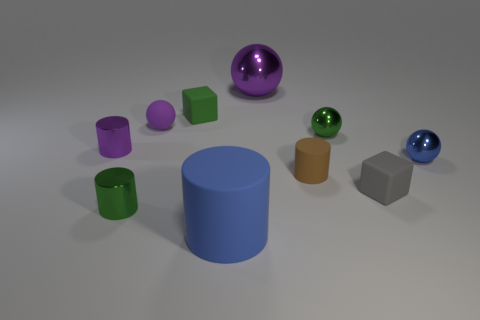Is there a tiny metallic thing that is on the left side of the large thing behind the big blue thing?
Your answer should be compact. Yes. There is a small rubber cube that is left of the small rubber block that is to the right of the green matte thing; how many tiny brown things are on the left side of it?
Offer a terse response. 0. There is a small shiny object that is both to the left of the big blue thing and behind the blue metallic sphere; what is its color?
Offer a terse response. Purple. How many small cylinders have the same color as the tiny matte ball?
Your response must be concise. 1. How many balls are either large gray metal things or brown matte objects?
Provide a short and direct response. 0. The other rubber cube that is the same size as the green cube is what color?
Your answer should be very brief. Gray. There is a brown cylinder on the left side of the green metallic object to the right of the purple shiny sphere; are there any small brown matte objects that are behind it?
Make the answer very short. No. What is the size of the green block?
Your response must be concise. Small. How many things are either tiny yellow matte cylinders or big purple shiny objects?
Provide a short and direct response. 1. What is the color of the other cylinder that is the same material as the big blue cylinder?
Your response must be concise. Brown. 